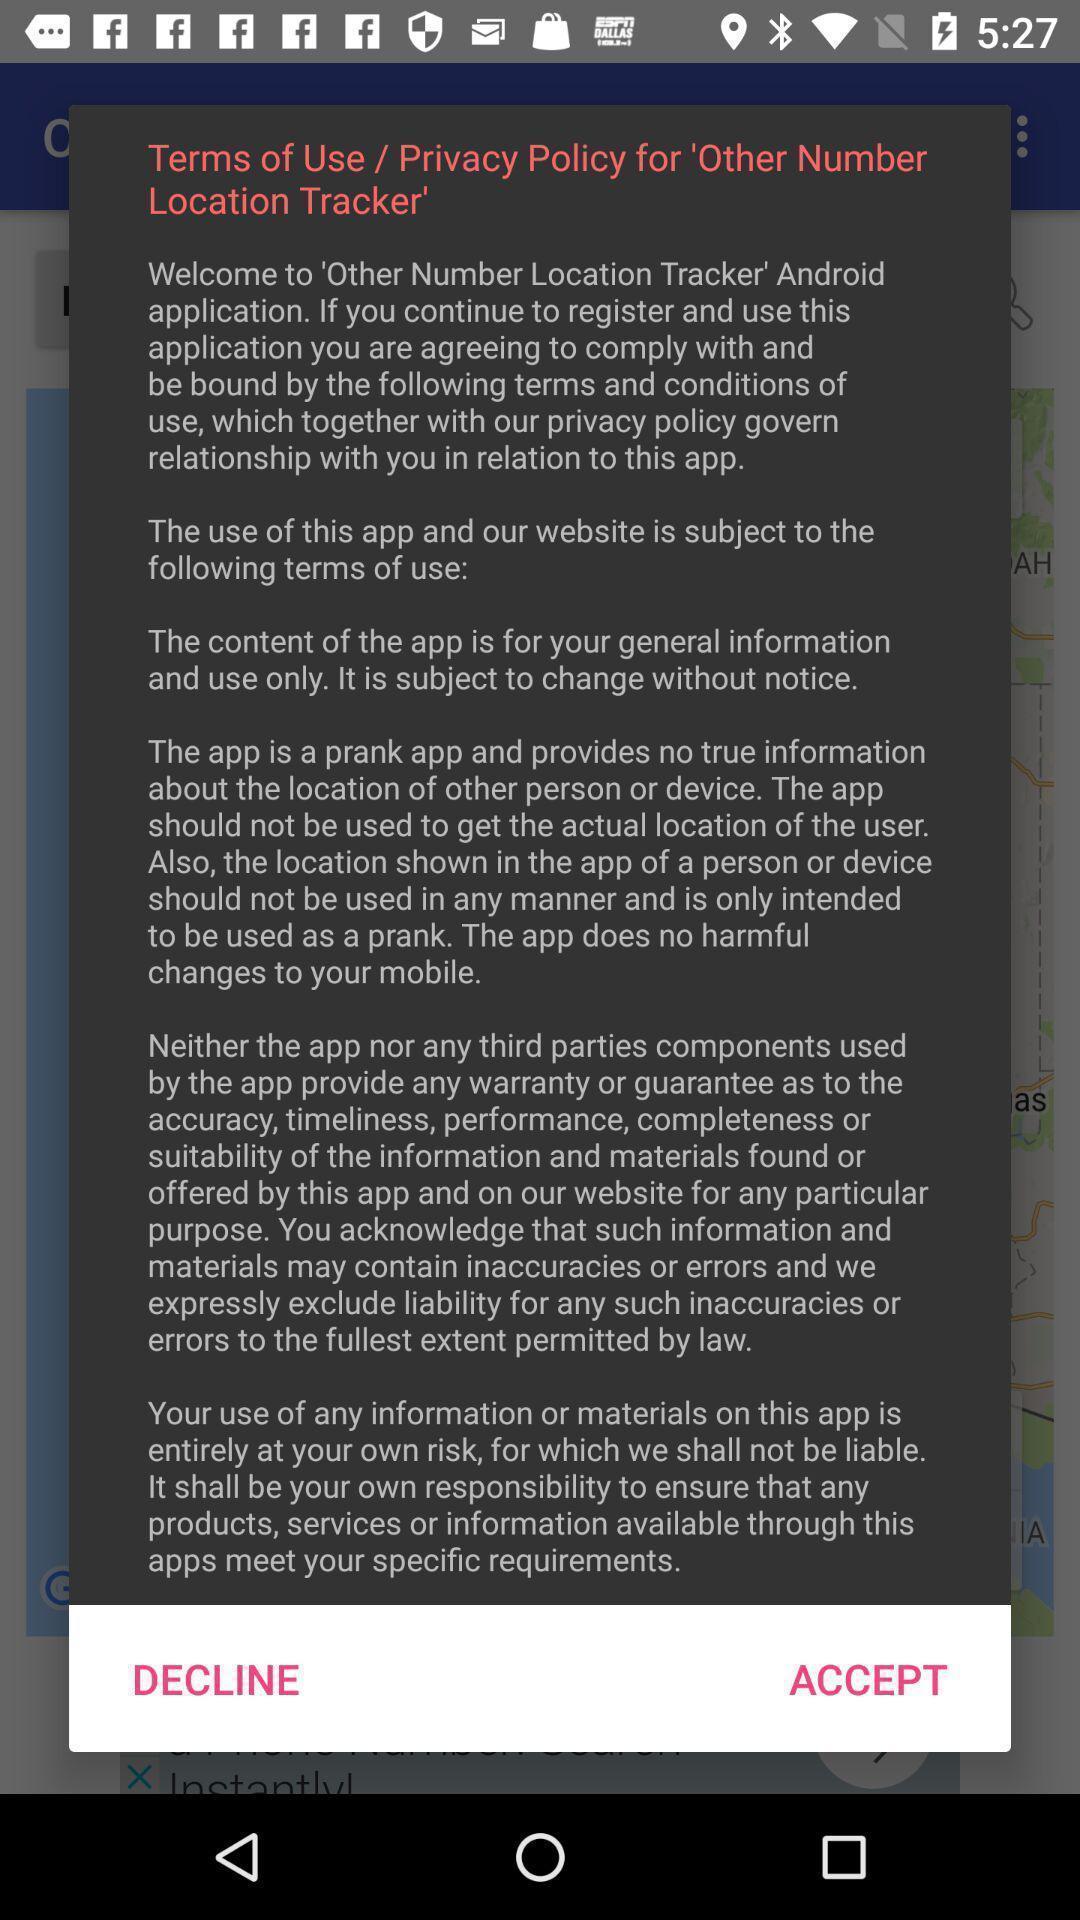Give me a summary of this screen capture. Pop-up displaying to accept privacy policy of the app. 